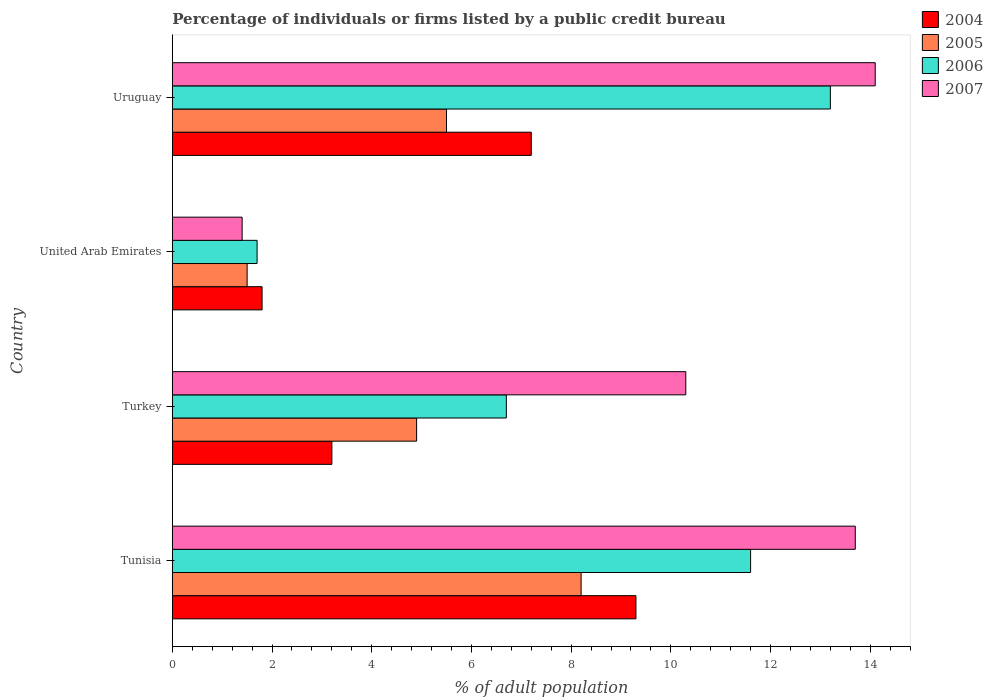How many different coloured bars are there?
Make the answer very short. 4. How many groups of bars are there?
Give a very brief answer. 4. Are the number of bars per tick equal to the number of legend labels?
Provide a short and direct response. Yes. How many bars are there on the 3rd tick from the top?
Make the answer very short. 4. How many bars are there on the 3rd tick from the bottom?
Provide a succinct answer. 4. In how many cases, is the number of bars for a given country not equal to the number of legend labels?
Your answer should be very brief. 0. Across all countries, what is the minimum percentage of population listed by a public credit bureau in 2006?
Offer a very short reply. 1.7. In which country was the percentage of population listed by a public credit bureau in 2004 maximum?
Your response must be concise. Tunisia. In which country was the percentage of population listed by a public credit bureau in 2007 minimum?
Your response must be concise. United Arab Emirates. What is the total percentage of population listed by a public credit bureau in 2007 in the graph?
Offer a very short reply. 39.5. What is the difference between the percentage of population listed by a public credit bureau in 2005 in Turkey and the percentage of population listed by a public credit bureau in 2004 in Uruguay?
Offer a terse response. -2.3. What is the average percentage of population listed by a public credit bureau in 2005 per country?
Offer a terse response. 5.03. What is the difference between the percentage of population listed by a public credit bureau in 2004 and percentage of population listed by a public credit bureau in 2006 in Uruguay?
Ensure brevity in your answer.  -6. What is the ratio of the percentage of population listed by a public credit bureau in 2005 in Tunisia to that in United Arab Emirates?
Your response must be concise. 5.47. Is the percentage of population listed by a public credit bureau in 2006 in Tunisia less than that in Uruguay?
Provide a succinct answer. Yes. What is the difference between the highest and the second highest percentage of population listed by a public credit bureau in 2007?
Your answer should be compact. 0.4. Is it the case that in every country, the sum of the percentage of population listed by a public credit bureau in 2007 and percentage of population listed by a public credit bureau in 2004 is greater than the percentage of population listed by a public credit bureau in 2005?
Your response must be concise. Yes. How many bars are there?
Your answer should be compact. 16. What is the difference between two consecutive major ticks on the X-axis?
Your response must be concise. 2. Are the values on the major ticks of X-axis written in scientific E-notation?
Provide a succinct answer. No. How are the legend labels stacked?
Provide a succinct answer. Vertical. What is the title of the graph?
Your response must be concise. Percentage of individuals or firms listed by a public credit bureau. What is the label or title of the X-axis?
Offer a very short reply. % of adult population. What is the % of adult population in 2004 in Tunisia?
Give a very brief answer. 9.3. What is the % of adult population in 2005 in Tunisia?
Your answer should be very brief. 8.2. What is the % of adult population of 2006 in Tunisia?
Ensure brevity in your answer.  11.6. What is the % of adult population of 2004 in Turkey?
Ensure brevity in your answer.  3.2. What is the % of adult population of 2006 in Turkey?
Ensure brevity in your answer.  6.7. What is the % of adult population in 2004 in United Arab Emirates?
Keep it short and to the point. 1.8. What is the % of adult population of 2005 in United Arab Emirates?
Your answer should be very brief. 1.5. What is the % of adult population in 2004 in Uruguay?
Make the answer very short. 7.2. What is the % of adult population of 2007 in Uruguay?
Your answer should be compact. 14.1. Across all countries, what is the maximum % of adult population in 2005?
Offer a terse response. 8.2. Across all countries, what is the maximum % of adult population of 2006?
Give a very brief answer. 13.2. Across all countries, what is the maximum % of adult population in 2007?
Make the answer very short. 14.1. Across all countries, what is the minimum % of adult population of 2004?
Provide a short and direct response. 1.8. Across all countries, what is the minimum % of adult population of 2005?
Offer a terse response. 1.5. What is the total % of adult population in 2005 in the graph?
Give a very brief answer. 20.1. What is the total % of adult population of 2006 in the graph?
Give a very brief answer. 33.2. What is the total % of adult population of 2007 in the graph?
Your answer should be compact. 39.5. What is the difference between the % of adult population of 2004 in Tunisia and that in Turkey?
Provide a short and direct response. 6.1. What is the difference between the % of adult population in 2005 in Tunisia and that in Turkey?
Make the answer very short. 3.3. What is the difference between the % of adult population of 2006 in Tunisia and that in Turkey?
Give a very brief answer. 4.9. What is the difference between the % of adult population in 2007 in Tunisia and that in Turkey?
Make the answer very short. 3.4. What is the difference between the % of adult population of 2006 in Tunisia and that in United Arab Emirates?
Your response must be concise. 9.9. What is the difference between the % of adult population in 2007 in Tunisia and that in United Arab Emirates?
Your answer should be compact. 12.3. What is the difference between the % of adult population of 2004 in Tunisia and that in Uruguay?
Give a very brief answer. 2.1. What is the difference between the % of adult population in 2006 in Tunisia and that in Uruguay?
Provide a short and direct response. -1.6. What is the difference between the % of adult population in 2005 in Turkey and that in United Arab Emirates?
Offer a terse response. 3.4. What is the difference between the % of adult population of 2004 in Turkey and that in Uruguay?
Offer a very short reply. -4. What is the difference between the % of adult population in 2006 in Turkey and that in Uruguay?
Provide a short and direct response. -6.5. What is the difference between the % of adult population in 2004 in United Arab Emirates and that in Uruguay?
Offer a very short reply. -5.4. What is the difference between the % of adult population of 2005 in United Arab Emirates and that in Uruguay?
Offer a terse response. -4. What is the difference between the % of adult population in 2006 in United Arab Emirates and that in Uruguay?
Your answer should be compact. -11.5. What is the difference between the % of adult population in 2004 in Tunisia and the % of adult population in 2007 in Turkey?
Keep it short and to the point. -1. What is the difference between the % of adult population of 2005 in Tunisia and the % of adult population of 2006 in Turkey?
Your answer should be very brief. 1.5. What is the difference between the % of adult population in 2005 in Tunisia and the % of adult population in 2007 in Turkey?
Provide a succinct answer. -2.1. What is the difference between the % of adult population in 2004 in Tunisia and the % of adult population in 2007 in United Arab Emirates?
Offer a terse response. 7.9. What is the difference between the % of adult population in 2006 in Tunisia and the % of adult population in 2007 in United Arab Emirates?
Your answer should be compact. 10.2. What is the difference between the % of adult population of 2004 in Tunisia and the % of adult population of 2005 in Uruguay?
Offer a terse response. 3.8. What is the difference between the % of adult population in 2004 in Tunisia and the % of adult population in 2006 in Uruguay?
Your answer should be very brief. -3.9. What is the difference between the % of adult population of 2004 in Tunisia and the % of adult population of 2007 in Uruguay?
Ensure brevity in your answer.  -4.8. What is the difference between the % of adult population in 2005 in Tunisia and the % of adult population in 2007 in Uruguay?
Provide a short and direct response. -5.9. What is the difference between the % of adult population of 2006 in Tunisia and the % of adult population of 2007 in Uruguay?
Your answer should be compact. -2.5. What is the difference between the % of adult population in 2004 in Turkey and the % of adult population in 2006 in United Arab Emirates?
Offer a terse response. 1.5. What is the difference between the % of adult population in 2004 in Turkey and the % of adult population in 2007 in United Arab Emirates?
Your response must be concise. 1.8. What is the difference between the % of adult population of 2004 in Turkey and the % of adult population of 2006 in Uruguay?
Provide a succinct answer. -10. What is the difference between the % of adult population of 2004 in Turkey and the % of adult population of 2007 in Uruguay?
Keep it short and to the point. -10.9. What is the difference between the % of adult population of 2004 in United Arab Emirates and the % of adult population of 2005 in Uruguay?
Make the answer very short. -3.7. What is the difference between the % of adult population of 2004 in United Arab Emirates and the % of adult population of 2006 in Uruguay?
Keep it short and to the point. -11.4. What is the difference between the % of adult population of 2005 in United Arab Emirates and the % of adult population of 2006 in Uruguay?
Give a very brief answer. -11.7. What is the difference between the % of adult population in 2005 in United Arab Emirates and the % of adult population in 2007 in Uruguay?
Your response must be concise. -12.6. What is the difference between the % of adult population of 2006 in United Arab Emirates and the % of adult population of 2007 in Uruguay?
Give a very brief answer. -12.4. What is the average % of adult population of 2004 per country?
Provide a short and direct response. 5.38. What is the average % of adult population of 2005 per country?
Keep it short and to the point. 5.03. What is the average % of adult population of 2006 per country?
Your answer should be very brief. 8.3. What is the average % of adult population in 2007 per country?
Your answer should be compact. 9.88. What is the difference between the % of adult population in 2004 and % of adult population in 2005 in Tunisia?
Give a very brief answer. 1.1. What is the difference between the % of adult population in 2004 and % of adult population in 2007 in Turkey?
Keep it short and to the point. -7.1. What is the difference between the % of adult population of 2005 and % of adult population of 2006 in Turkey?
Your response must be concise. -1.8. What is the difference between the % of adult population in 2006 and % of adult population in 2007 in Turkey?
Keep it short and to the point. -3.6. What is the difference between the % of adult population of 2004 and % of adult population of 2006 in United Arab Emirates?
Your answer should be compact. 0.1. What is the difference between the % of adult population in 2004 and % of adult population in 2007 in United Arab Emirates?
Offer a terse response. 0.4. What is the difference between the % of adult population of 2005 and % of adult population of 2007 in United Arab Emirates?
Your answer should be compact. 0.1. What is the difference between the % of adult population in 2006 and % of adult population in 2007 in United Arab Emirates?
Provide a short and direct response. 0.3. What is the difference between the % of adult population of 2006 and % of adult population of 2007 in Uruguay?
Keep it short and to the point. -0.9. What is the ratio of the % of adult population in 2004 in Tunisia to that in Turkey?
Make the answer very short. 2.91. What is the ratio of the % of adult population in 2005 in Tunisia to that in Turkey?
Provide a short and direct response. 1.67. What is the ratio of the % of adult population of 2006 in Tunisia to that in Turkey?
Offer a very short reply. 1.73. What is the ratio of the % of adult population in 2007 in Tunisia to that in Turkey?
Keep it short and to the point. 1.33. What is the ratio of the % of adult population of 2004 in Tunisia to that in United Arab Emirates?
Offer a terse response. 5.17. What is the ratio of the % of adult population in 2005 in Tunisia to that in United Arab Emirates?
Make the answer very short. 5.47. What is the ratio of the % of adult population in 2006 in Tunisia to that in United Arab Emirates?
Keep it short and to the point. 6.82. What is the ratio of the % of adult population in 2007 in Tunisia to that in United Arab Emirates?
Keep it short and to the point. 9.79. What is the ratio of the % of adult population of 2004 in Tunisia to that in Uruguay?
Your answer should be very brief. 1.29. What is the ratio of the % of adult population of 2005 in Tunisia to that in Uruguay?
Keep it short and to the point. 1.49. What is the ratio of the % of adult population of 2006 in Tunisia to that in Uruguay?
Keep it short and to the point. 0.88. What is the ratio of the % of adult population of 2007 in Tunisia to that in Uruguay?
Your answer should be very brief. 0.97. What is the ratio of the % of adult population in 2004 in Turkey to that in United Arab Emirates?
Offer a terse response. 1.78. What is the ratio of the % of adult population of 2005 in Turkey to that in United Arab Emirates?
Ensure brevity in your answer.  3.27. What is the ratio of the % of adult population in 2006 in Turkey to that in United Arab Emirates?
Your answer should be very brief. 3.94. What is the ratio of the % of adult population in 2007 in Turkey to that in United Arab Emirates?
Offer a very short reply. 7.36. What is the ratio of the % of adult population in 2004 in Turkey to that in Uruguay?
Your answer should be very brief. 0.44. What is the ratio of the % of adult population in 2005 in Turkey to that in Uruguay?
Your response must be concise. 0.89. What is the ratio of the % of adult population in 2006 in Turkey to that in Uruguay?
Give a very brief answer. 0.51. What is the ratio of the % of adult population of 2007 in Turkey to that in Uruguay?
Offer a terse response. 0.73. What is the ratio of the % of adult population in 2004 in United Arab Emirates to that in Uruguay?
Your answer should be compact. 0.25. What is the ratio of the % of adult population of 2005 in United Arab Emirates to that in Uruguay?
Keep it short and to the point. 0.27. What is the ratio of the % of adult population in 2006 in United Arab Emirates to that in Uruguay?
Ensure brevity in your answer.  0.13. What is the ratio of the % of adult population in 2007 in United Arab Emirates to that in Uruguay?
Offer a terse response. 0.1. What is the difference between the highest and the second highest % of adult population in 2004?
Your answer should be compact. 2.1. What is the difference between the highest and the second highest % of adult population in 2006?
Your answer should be compact. 1.6. What is the difference between the highest and the second highest % of adult population in 2007?
Provide a succinct answer. 0.4. What is the difference between the highest and the lowest % of adult population in 2006?
Offer a terse response. 11.5. 